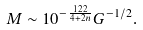Convert formula to latex. <formula><loc_0><loc_0><loc_500><loc_500>M \sim 1 0 ^ { - \frac { 1 2 2 } { 4 + 2 n } } G ^ { - 1 / 2 } .</formula> 